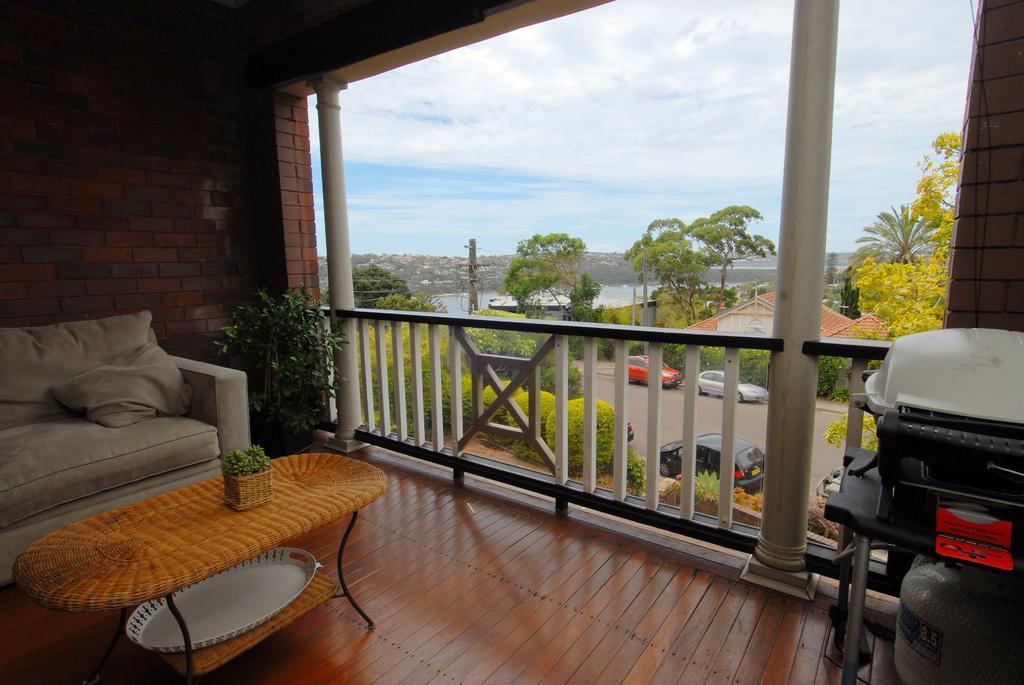Please provide a concise description of this image. In the image the left side we can see the couch in front of couch there is a table,on table there is a vase. And back of the sofa there is a brick wall,and coming to the right corner there is some machine. And in the center there is a sky with clouds and some trees and house on the top with red roof. And in the center there is a road with few vehicles. 